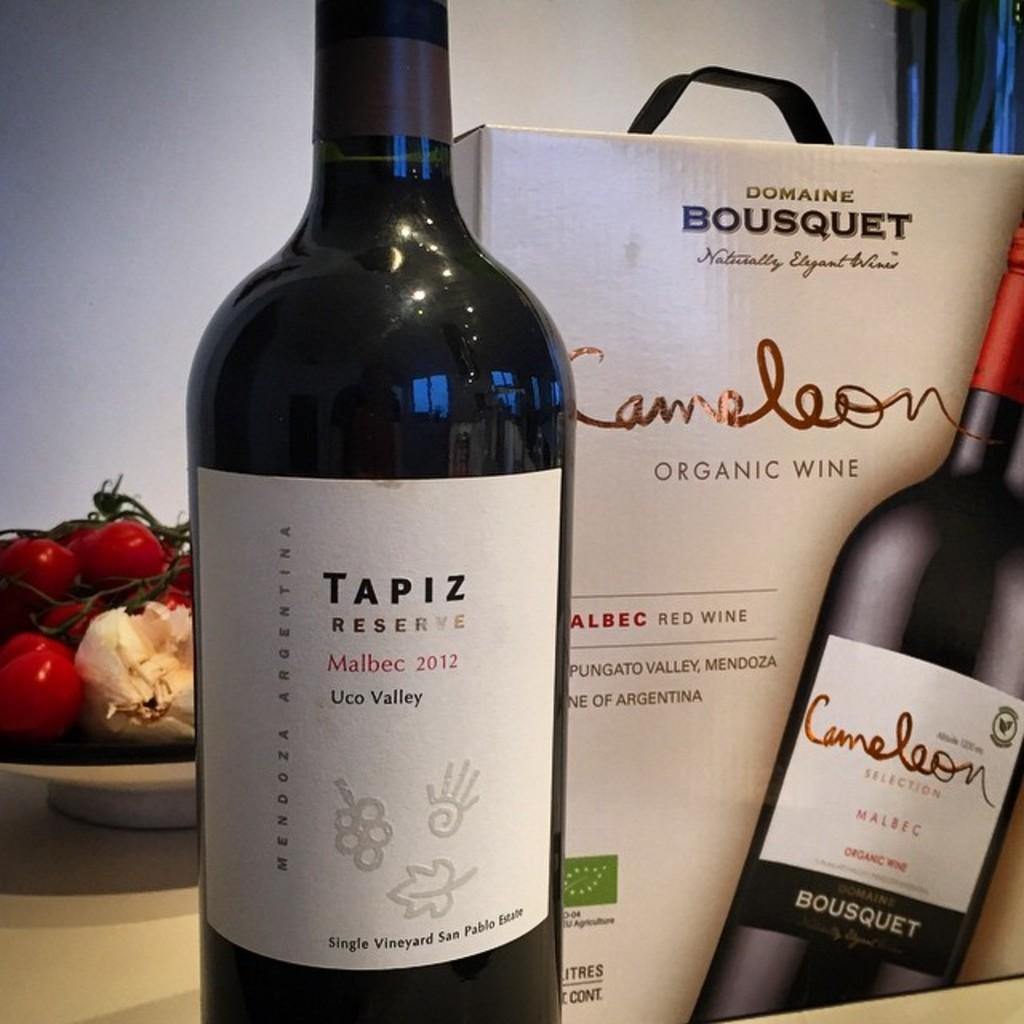<image>
Summarize the visual content of the image. A bottle of Tapiz Reserve Malbec wine next to a box with a wine bottle on it. 